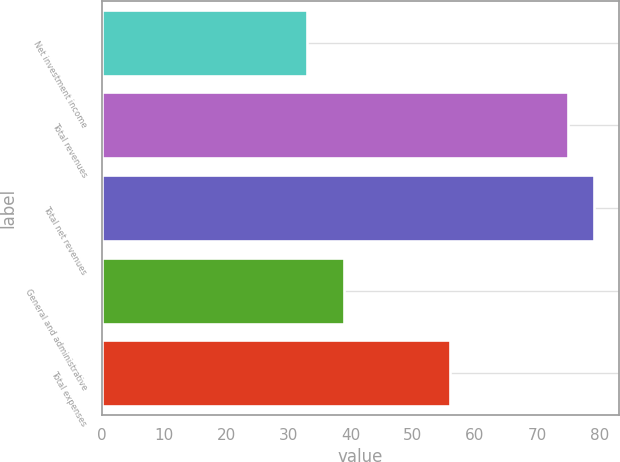Convert chart to OTSL. <chart><loc_0><loc_0><loc_500><loc_500><bar_chart><fcel>Net investment income<fcel>Total revenues<fcel>Total net revenues<fcel>General and administrative<fcel>Total expenses<nl><fcel>33<fcel>75<fcel>79.2<fcel>39<fcel>56<nl></chart> 